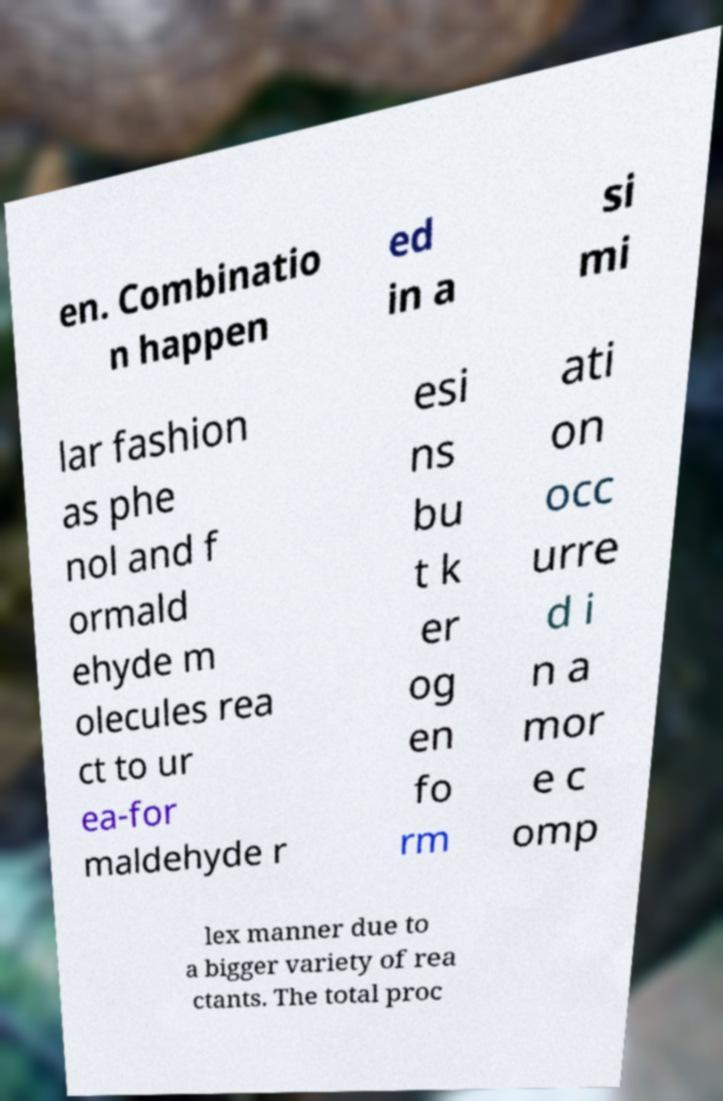I need the written content from this picture converted into text. Can you do that? en. Combinatio n happen ed in a si mi lar fashion as phe nol and f ormald ehyde m olecules rea ct to ur ea-for maldehyde r esi ns bu t k er og en fo rm ati on occ urre d i n a mor e c omp lex manner due to a bigger variety of rea ctants. The total proc 